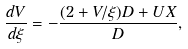Convert formula to latex. <formula><loc_0><loc_0><loc_500><loc_500>\frac { d V } { d \xi } = - \frac { ( 2 + V / \xi ) D + U X } { D } ,</formula> 